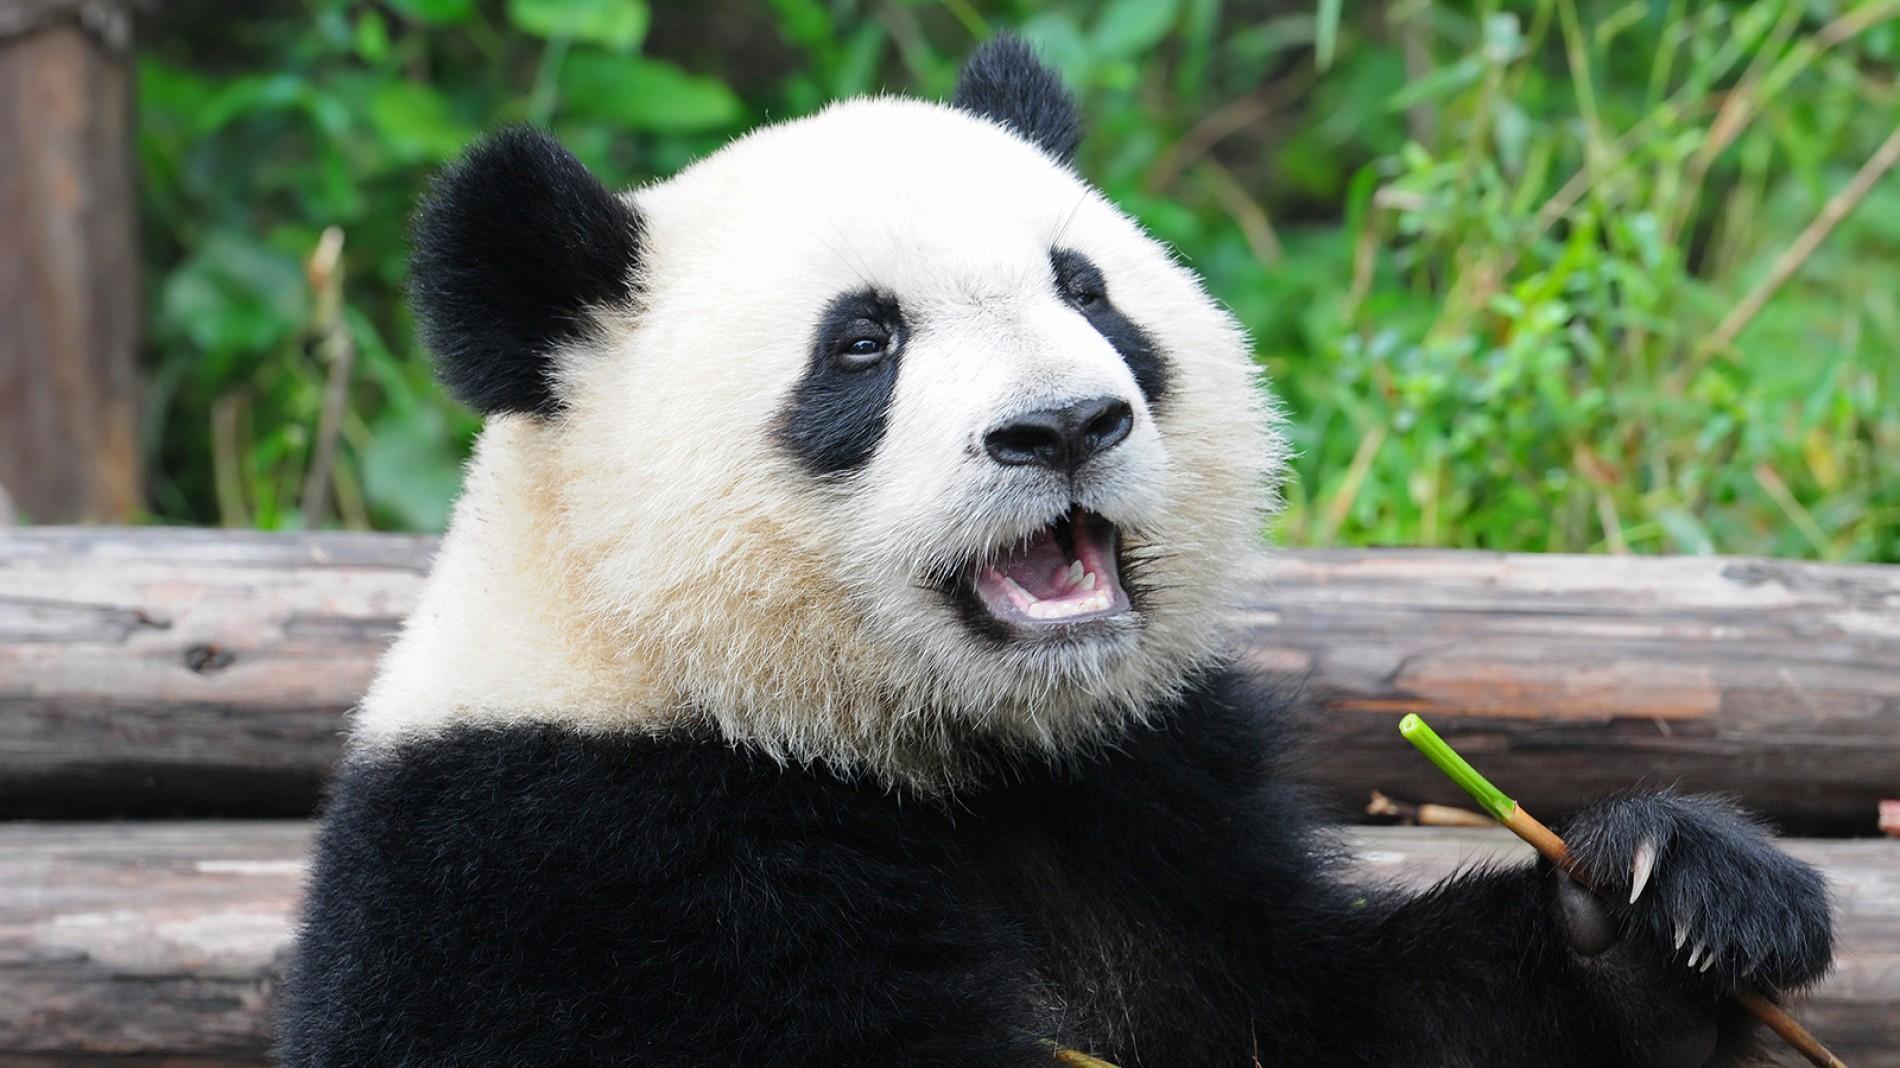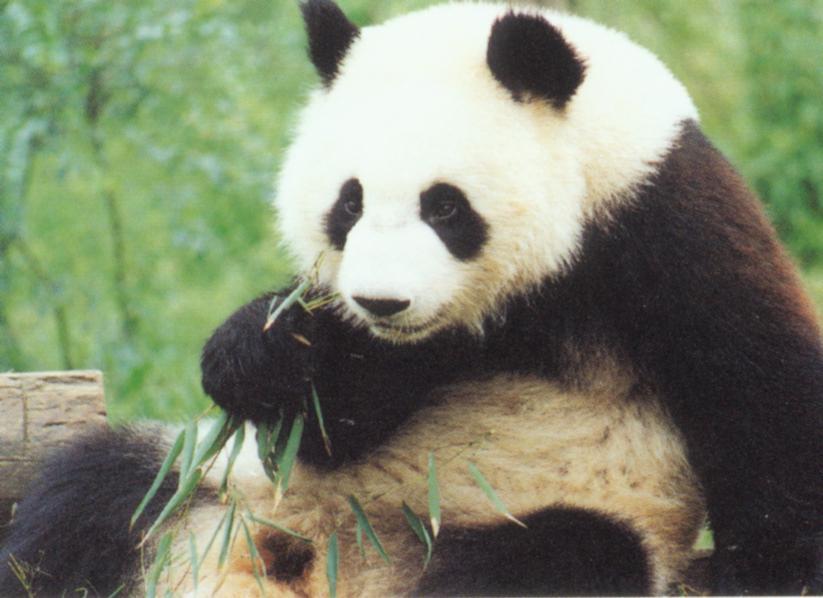The first image is the image on the left, the second image is the image on the right. Analyze the images presented: Is the assertion "An image shows two pandas in close contact." valid? Answer yes or no. No. The first image is the image on the left, the second image is the image on the right. Analyze the images presented: Is the assertion "The panda in at least one of the images is holding a bamboo shoot." valid? Answer yes or no. Yes. 